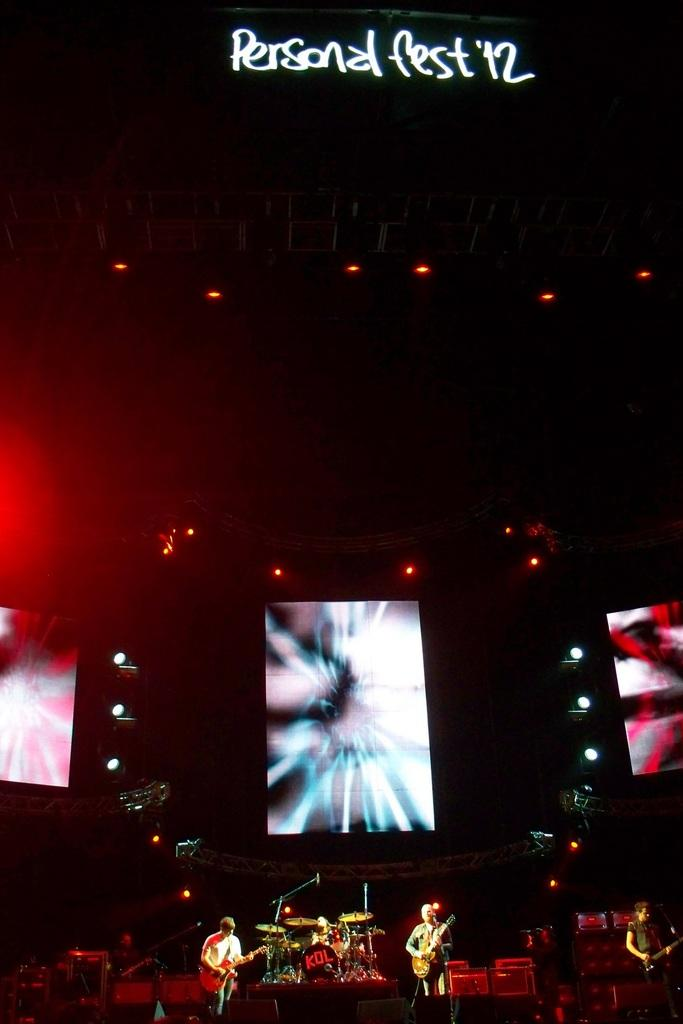What is the main feature of the image? There is a stage in the image. What are the two persons on the stage doing? They are playing musical instruments on the stage. What can be seen in the background of the image? There are colorful lights in the background of the image. What type of breakfast is being served on the stage? There is no breakfast being served on the stage; the image features two persons playing musical instruments on a stage with colorful lights in the background. 